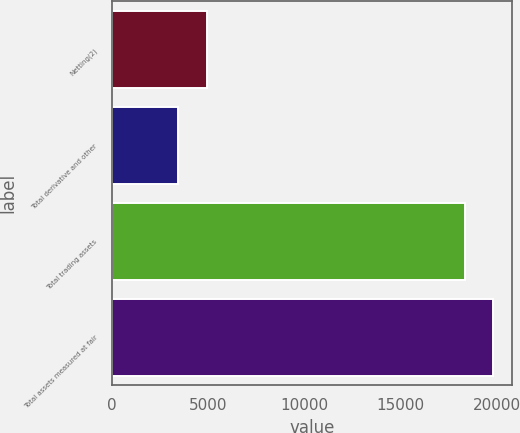Convert chart. <chart><loc_0><loc_0><loc_500><loc_500><bar_chart><fcel>Netting(2)<fcel>Total derivative and other<fcel>Total trading assets<fcel>Total assets measured at fair<nl><fcel>4931<fcel>3425<fcel>18344<fcel>19836.7<nl></chart> 